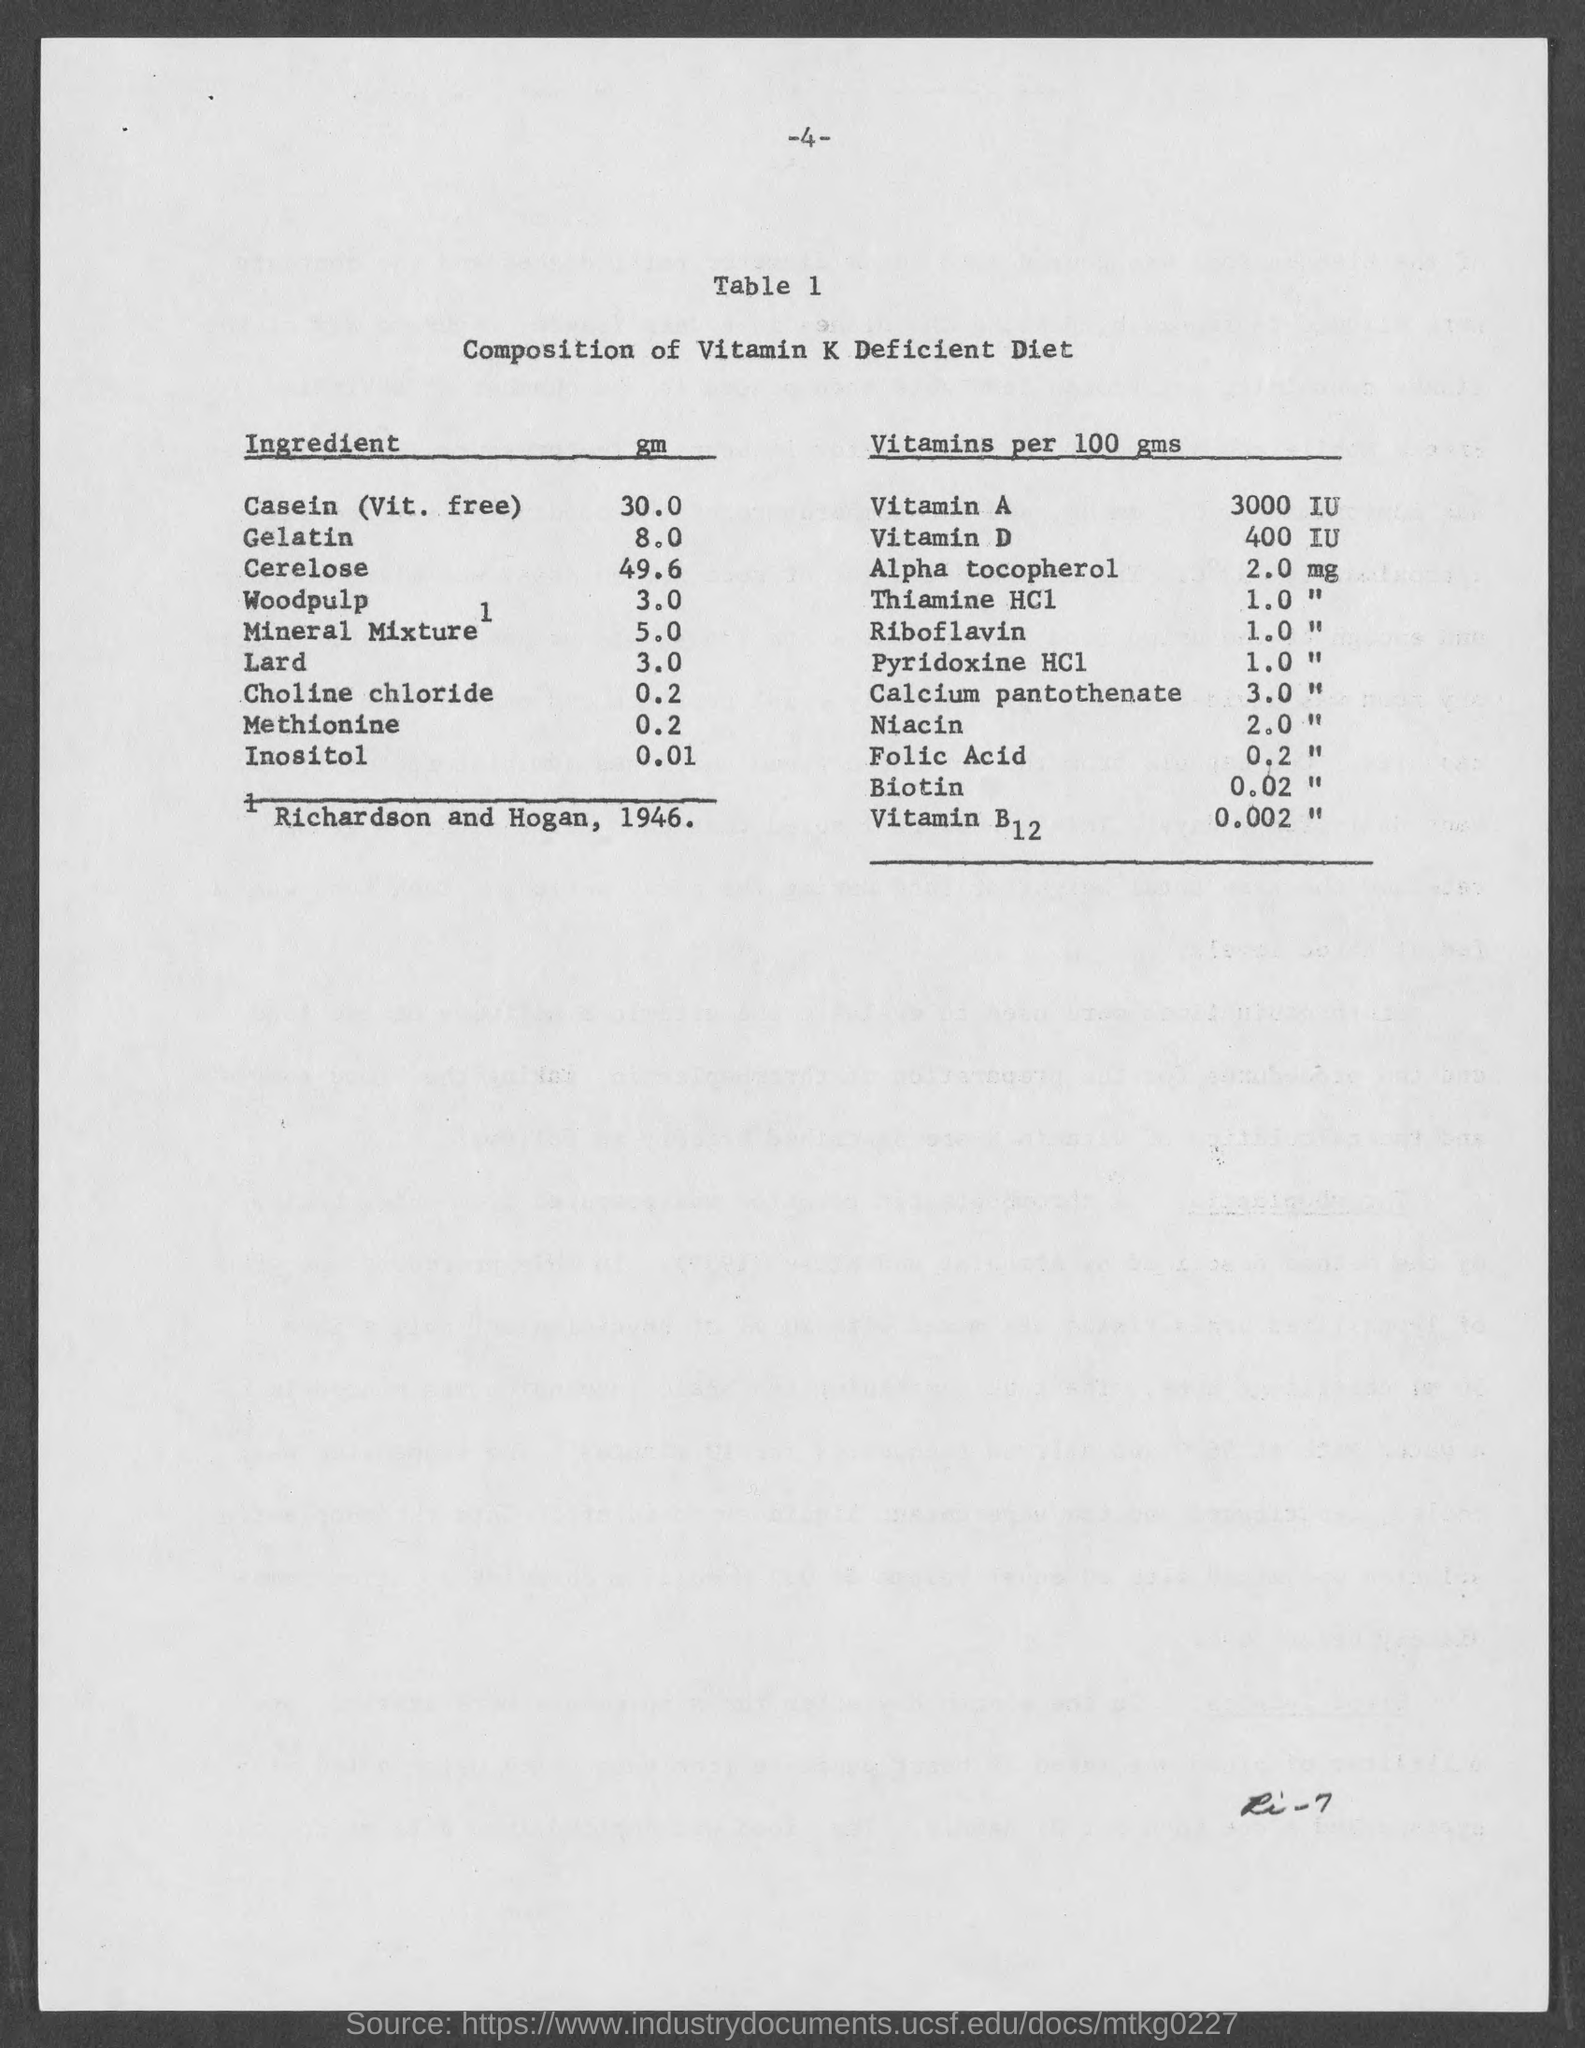What is the title of table 1?
Give a very brief answer. Composition of Vitamin K Deficient Diet. What is the amount of vitamin a in 100 gms?
Provide a succinct answer. 3000 IU. What is the amount of vitamin d in 100 gms ?
Your answer should be compact. 400 IU. What is the amount of alpha tocopherol in 100 gms ?
Your answer should be compact. 2.0 mg. 